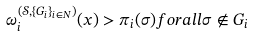Convert formula to latex. <formula><loc_0><loc_0><loc_500><loc_500>\omega ^ { ( \mathcal { S } , \{ G _ { i } \} _ { i \in N } ) } _ { i } ( x ) > \pi _ { i } ( \sigma ) f o r a l l \sigma \not \in G _ { i }</formula> 